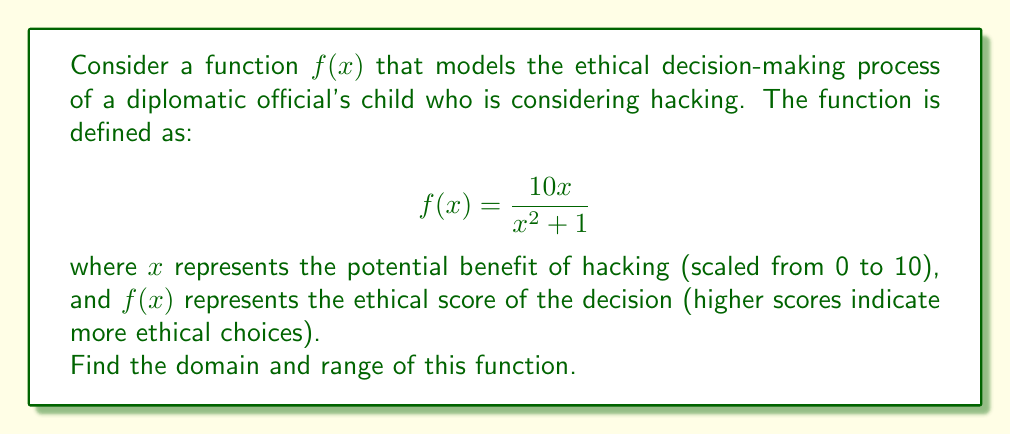Teach me how to tackle this problem. To find the domain and range of this function, we'll follow these steps:

1. Domain:
   The domain is all real numbers for which the function is defined. In this case, we need to check for any values of $x$ that would make the denominator zero.

   $x^2 + 1 = 0$
   $x^2 = -1$

   This equation has no real solutions because a squared number can never be negative. Therefore, the denominator is never zero for any real $x$.

   Thus, the domain is all real numbers: $(-\infty, \infty)$

2. Range:
   To find the range, we'll use the following steps:
   a) Rewrite the function in a form that's easier to analyze:
      $$f(x) = \frac{10x}{x^2 + 1} = 10 \cdot \frac{x}{x^2 + 1}$$

   b) Recognize that $\frac{x}{x^2 + 1}$ is a standard form with a maximum value of $\frac{1}{2}$ and a minimum value of $-\frac{1}{2}$.

   c) Therefore, the range of $f(x)$ will be from $10 \cdot (-\frac{1}{2})$ to $10 \cdot \frac{1}{2}$:

      $[-5, 5]$

   We can verify this by considering the limits:
   $$\lim_{x \to \infty} f(x) = \lim_{x \to -\infty} f(x) = 0$$

   And the maximum/minimum points occur when $x = \pm 1$:
   $$f(1) = 5 \text{ and } f(-1) = -5$$
Answer: Domain: $(-\infty, \infty)$; Range: $[-5, 5]$ 